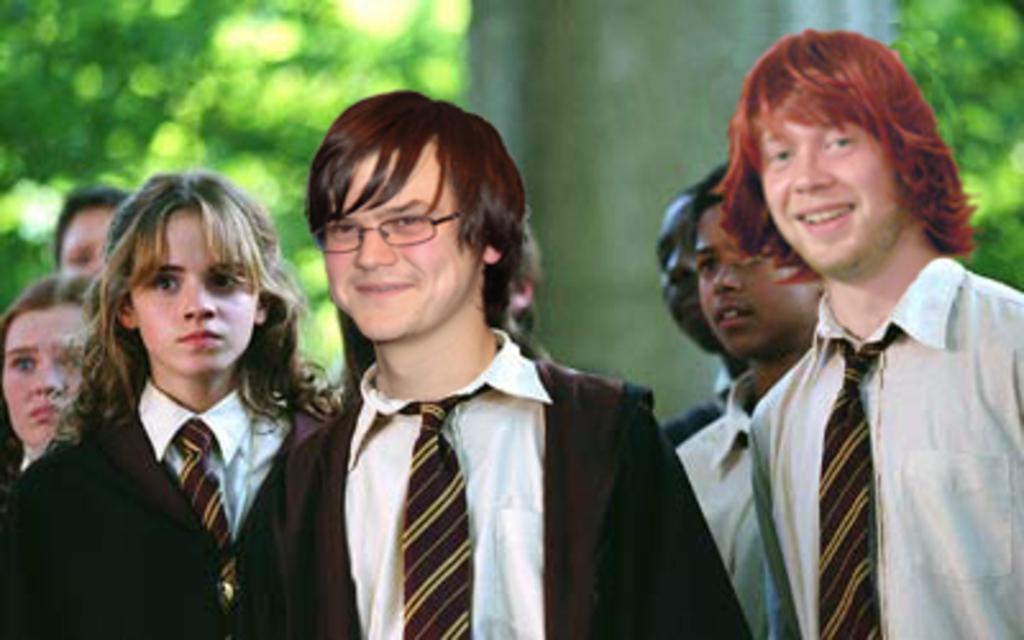How would you summarize this image in a sentence or two? In this image there are a group of boys towards the bottom of the image, there are girls towards the bottom of the image, they are wearing uniforms, there is a pillar towards the top of the image, at the background of the image there are trees, the background of the image is blurred. 